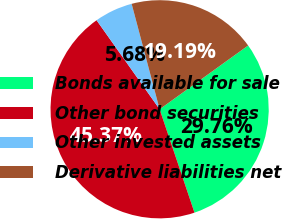Convert chart to OTSL. <chart><loc_0><loc_0><loc_500><loc_500><pie_chart><fcel>Bonds available for sale<fcel>Other bond securities<fcel>Other invested assets<fcel>Derivative liabilities net<nl><fcel>29.76%<fcel>45.37%<fcel>5.68%<fcel>19.19%<nl></chart> 